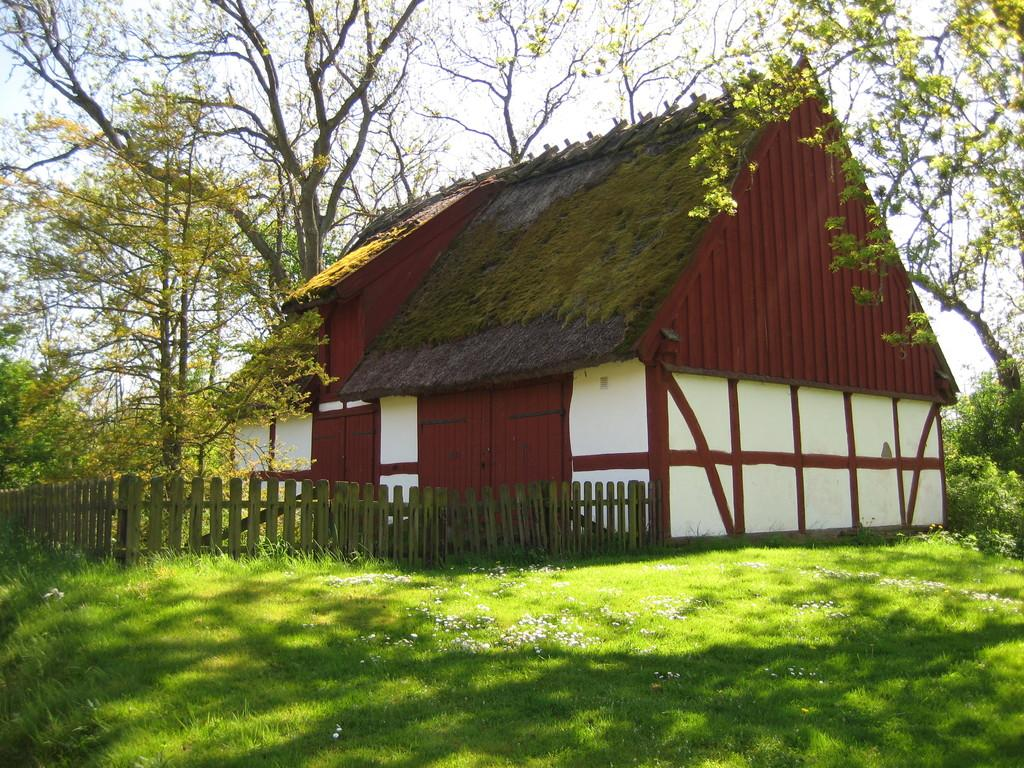What type of structure is in the image? There is a hut in the image. What material is used for the fencing around the hut? The hut has wooden fencing. What type of vegetation is present in the image? There is grass in the image. What else can be seen in the image besides the hut and grass? There are trees in the image. What part of the natural environment is visible in the image? The sky is visible in the image. How does the hut crush the rainstorm in the image? There is no rainstorm present in the image, and therefore the hut cannot crush it. 